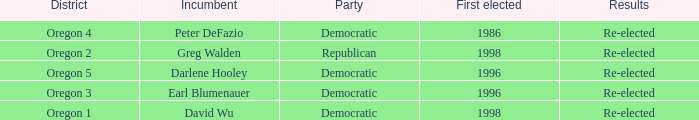What was the result of the Oregon 5 District incumbent who was first elected in 1996? Re-elected. 